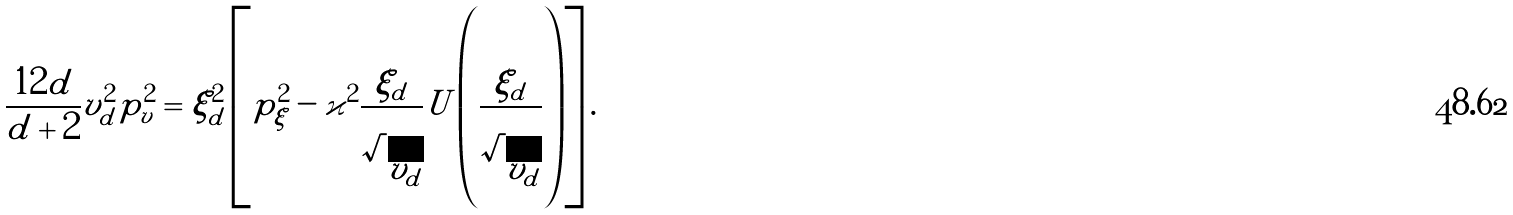<formula> <loc_0><loc_0><loc_500><loc_500>\frac { 1 2 d } { d + 2 } v _ { d } ^ { 2 } p ^ { 2 } _ { v } = \xi ^ { 2 } _ { d } \left [ p ^ { 2 } _ { \xi } - \varkappa ^ { 2 } \frac { \xi _ { d } } { \sqrt { v _ { d } } } U \left ( \frac { \xi _ { d } } { \sqrt { v _ { d } } } \right ) \right ] .</formula> 